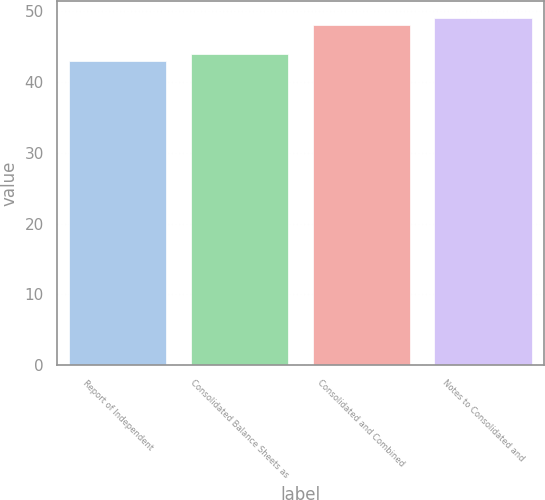Convert chart. <chart><loc_0><loc_0><loc_500><loc_500><bar_chart><fcel>Report of Independent<fcel>Consolidated Balance Sheets as<fcel>Consolidated and Combined<fcel>Notes to Consolidated and<nl><fcel>43<fcel>44<fcel>48<fcel>49<nl></chart> 